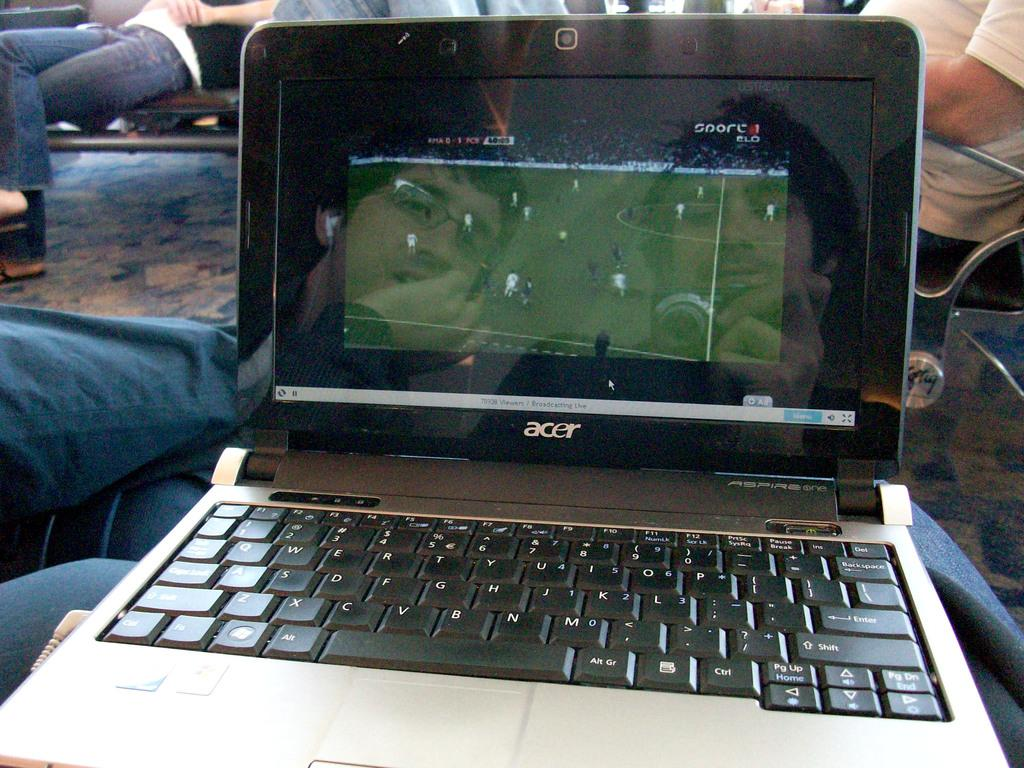<image>
Create a compact narrative representing the image presented. An Acer brand computer is open with a sports game on the screen. 